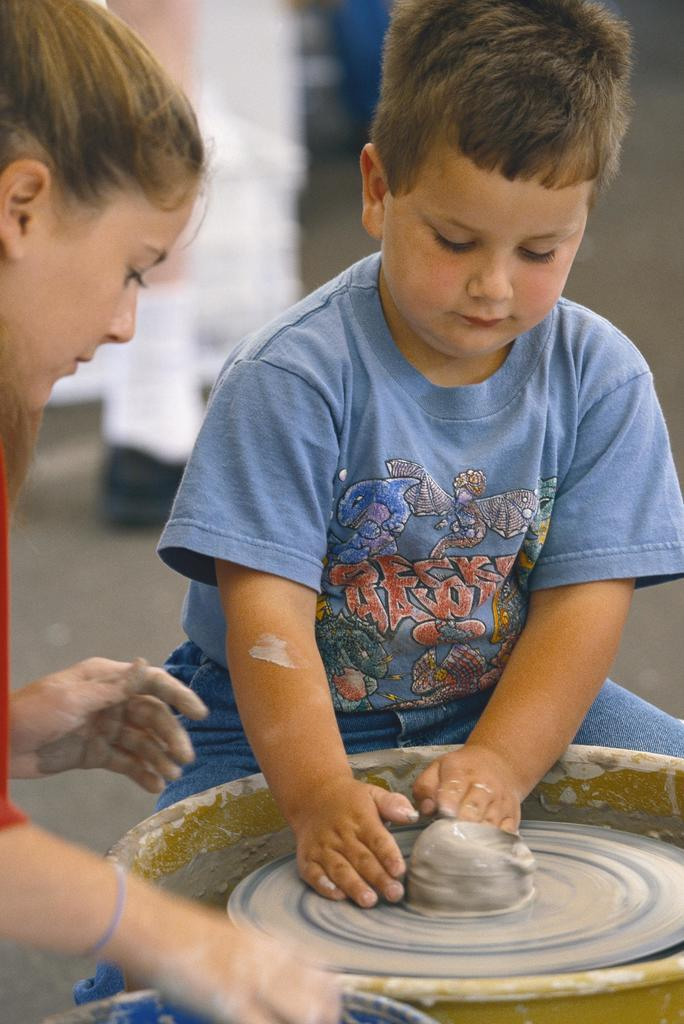What can be seen in the image? There are kids in the image. What are the kids doing in the image? The kids are making a pot. Can you describe the background of the image? The background of the image is blurred. Where can the receipt for the pot be found in the image? There is no receipt present in the image. How many people are in the crowd in the image? There is no crowd present in the image. 